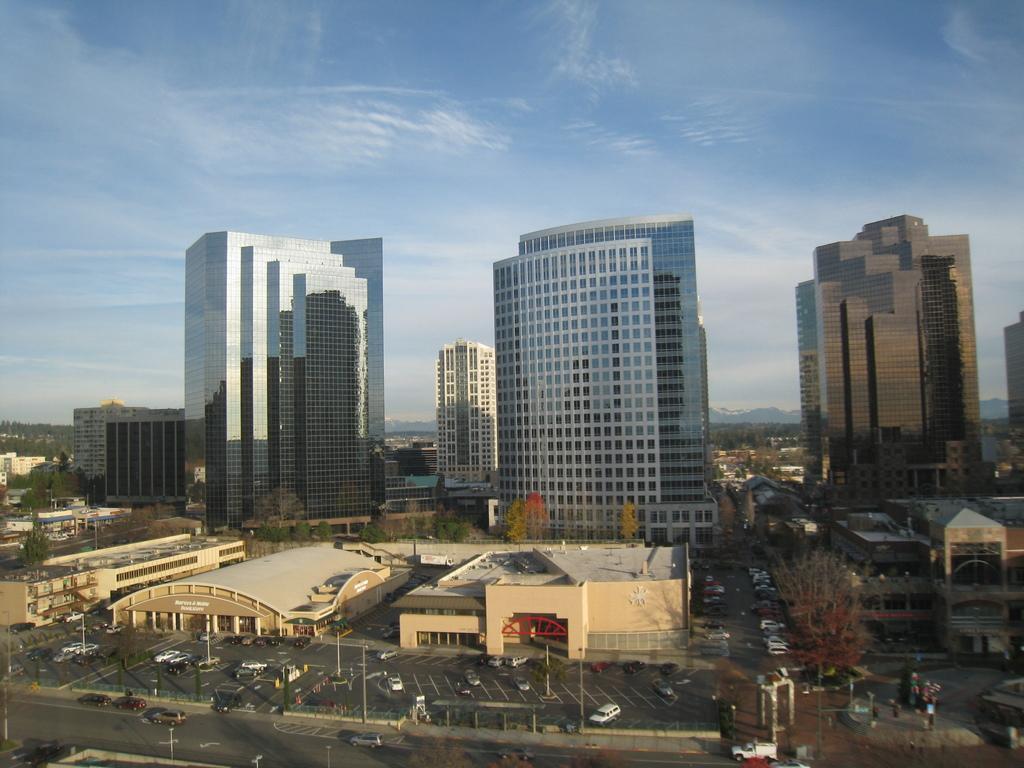Could you give a brief overview of what you see in this image? This is the picture of a city. In this image there are buildings, trees and poles. In the foreground there are vehicles on the road. At the back there are mountains. At the top there is sky and there are clouds. At the bottom there is a road. 